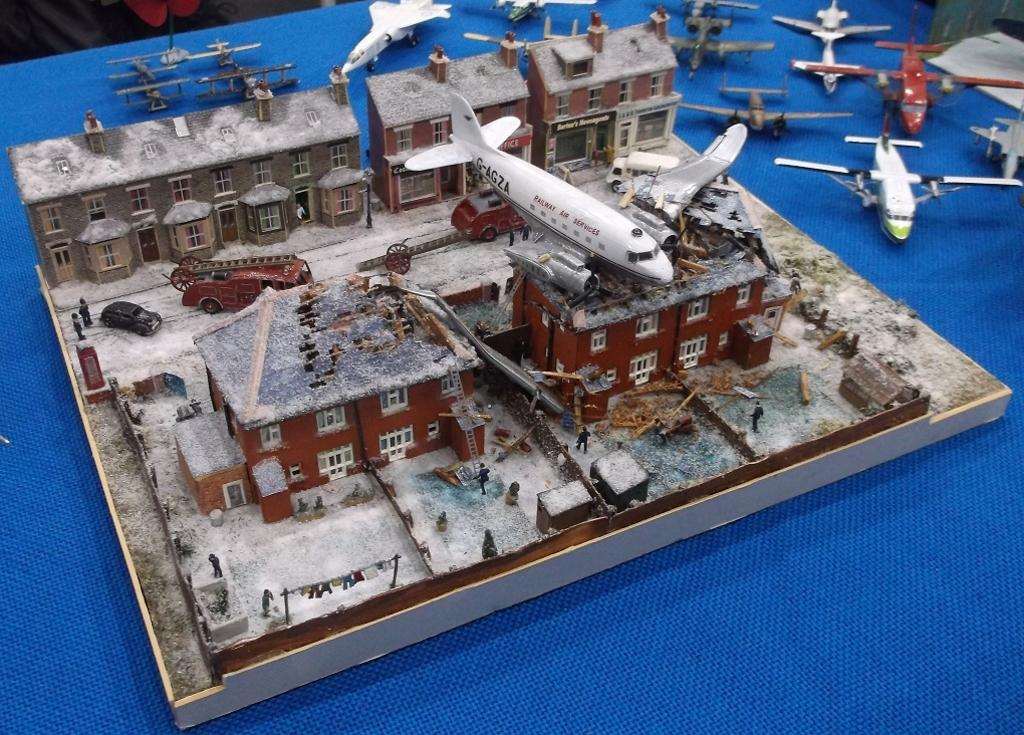What type of toy is present in the image? There is a toy house in the image. Can you describe the toy house? The toy house is a miniature. What else can be seen on the table in the image? There are many planes on a table in the image. What color is the cloth at the bottom of the image? The cloth at the bottom of the image is blue. What type of apparel is being worn by the toy house in the image? The toy house is an inanimate object and does not wear apparel. 